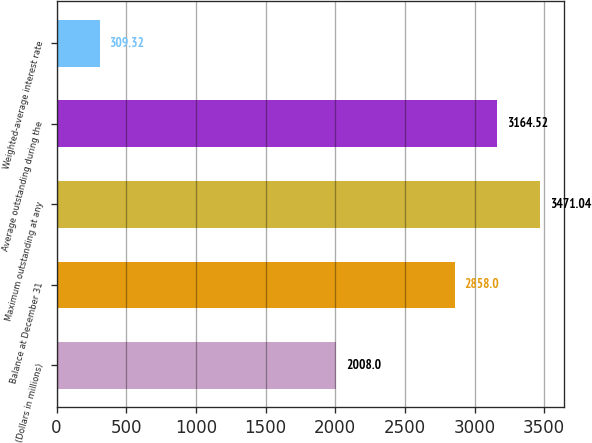<chart> <loc_0><loc_0><loc_500><loc_500><bar_chart><fcel>(Dollars in millions)<fcel>Balance at December 31<fcel>Maximum outstanding at any<fcel>Average outstanding during the<fcel>Weighted-average interest rate<nl><fcel>2008<fcel>2858<fcel>3471.04<fcel>3164.52<fcel>309.32<nl></chart> 